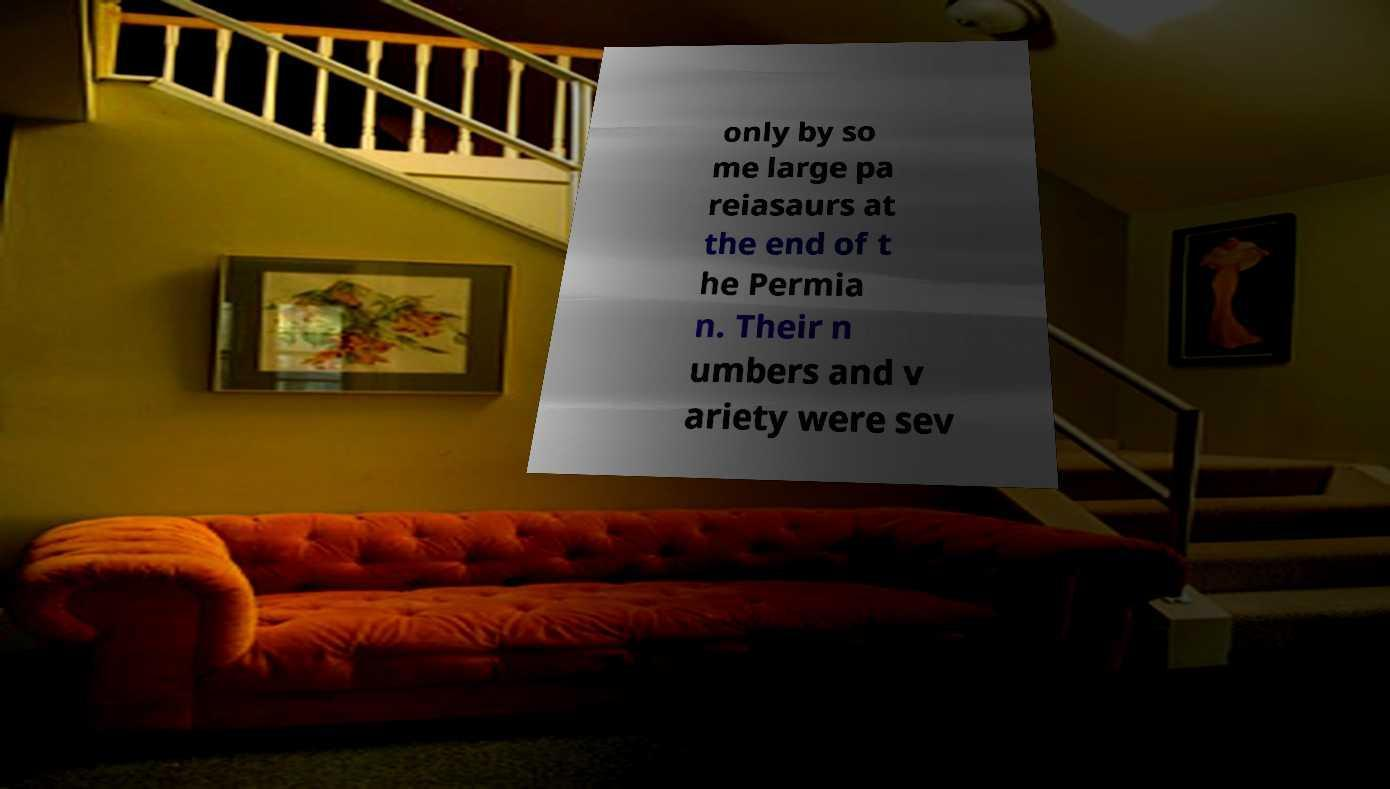Please identify and transcribe the text found in this image. only by so me large pa reiasaurs at the end of t he Permia n. Their n umbers and v ariety were sev 